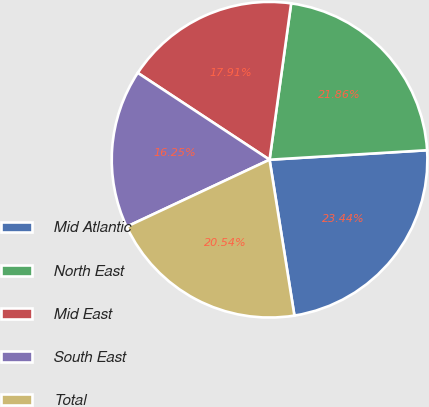<chart> <loc_0><loc_0><loc_500><loc_500><pie_chart><fcel>Mid Atlantic<fcel>North East<fcel>Mid East<fcel>South East<fcel>Total<nl><fcel>23.44%<fcel>21.86%<fcel>17.91%<fcel>16.25%<fcel>20.54%<nl></chart> 